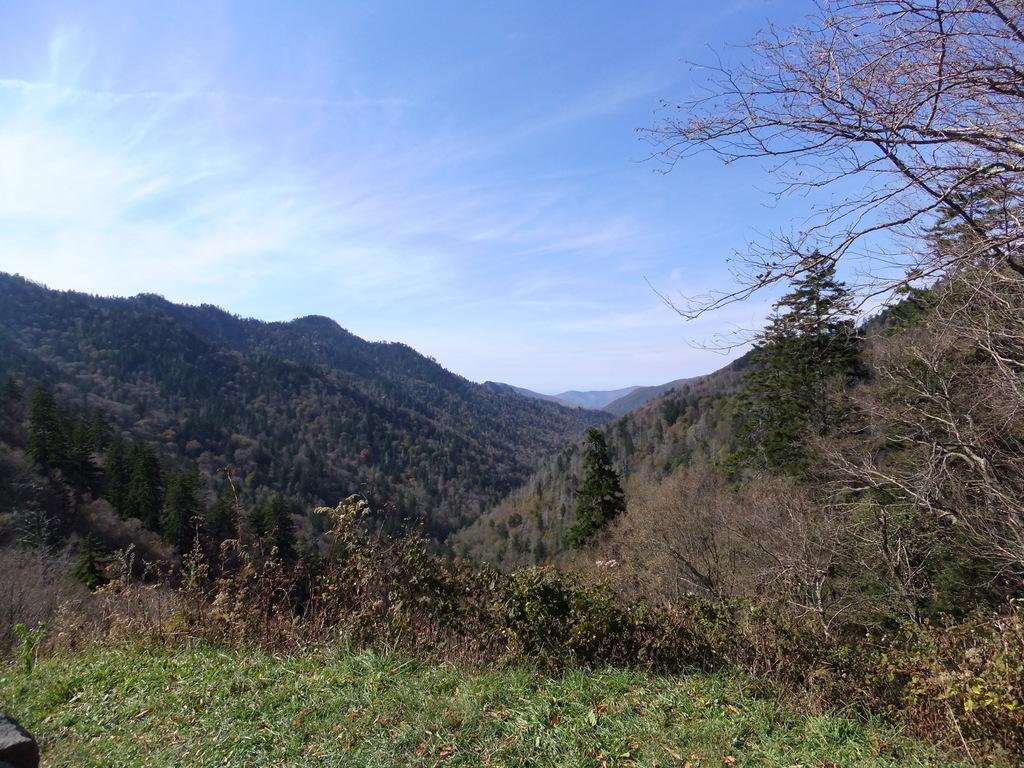Can you describe this image briefly? In this image I can see number of trees, mountains and also I can see clear view of sky. 